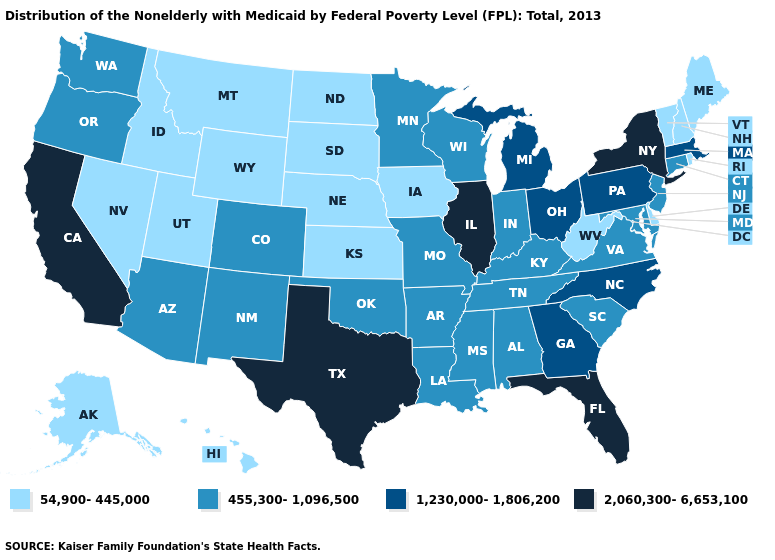Among the states that border Georgia , does Florida have the highest value?
Quick response, please. Yes. Does the first symbol in the legend represent the smallest category?
Short answer required. Yes. What is the value of Wyoming?
Write a very short answer. 54,900-445,000. What is the highest value in the USA?
Keep it brief. 2,060,300-6,653,100. Does New Hampshire have a lower value than Louisiana?
Keep it brief. Yes. What is the value of Arizona?
Concise answer only. 455,300-1,096,500. Name the states that have a value in the range 2,060,300-6,653,100?
Be succinct. California, Florida, Illinois, New York, Texas. What is the highest value in states that border Utah?
Write a very short answer. 455,300-1,096,500. Is the legend a continuous bar?
Be succinct. No. What is the value of Kansas?
Write a very short answer. 54,900-445,000. Name the states that have a value in the range 455,300-1,096,500?
Concise answer only. Alabama, Arizona, Arkansas, Colorado, Connecticut, Indiana, Kentucky, Louisiana, Maryland, Minnesota, Mississippi, Missouri, New Jersey, New Mexico, Oklahoma, Oregon, South Carolina, Tennessee, Virginia, Washington, Wisconsin. Does the first symbol in the legend represent the smallest category?
Write a very short answer. Yes. What is the lowest value in the MidWest?
Short answer required. 54,900-445,000. Name the states that have a value in the range 1,230,000-1,806,200?
Answer briefly. Georgia, Massachusetts, Michigan, North Carolina, Ohio, Pennsylvania. Does the first symbol in the legend represent the smallest category?
Answer briefly. Yes. 